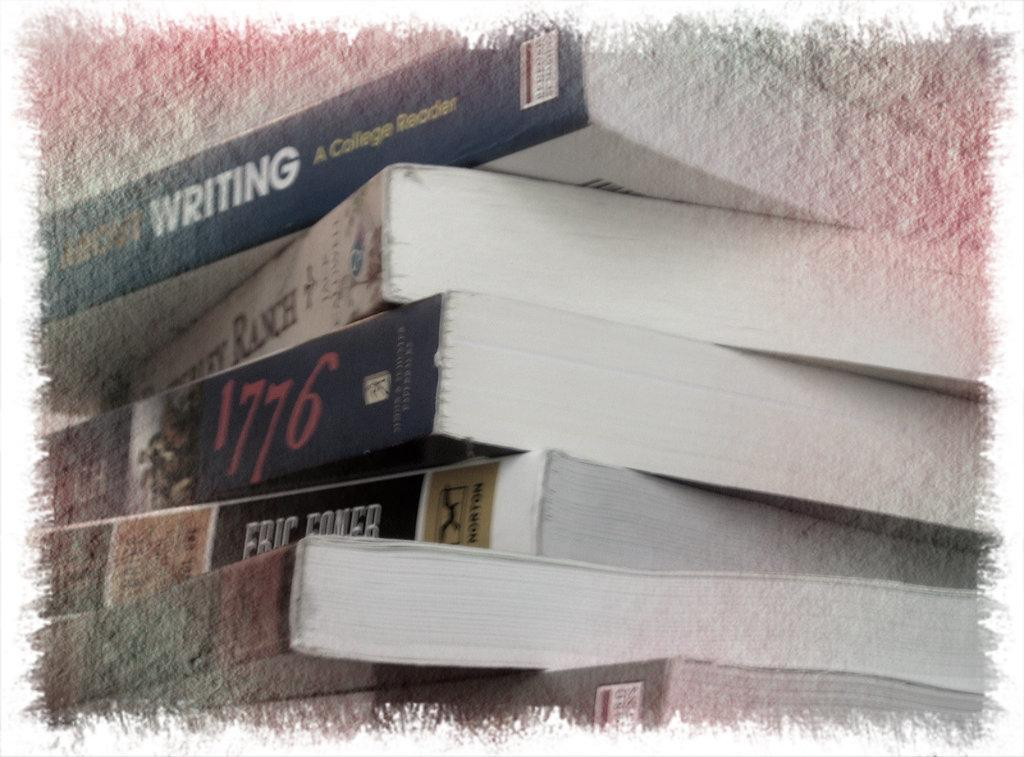<image>
Offer a succinct explanation of the picture presented. A collection of six books with the number 1776 written on one of them. 